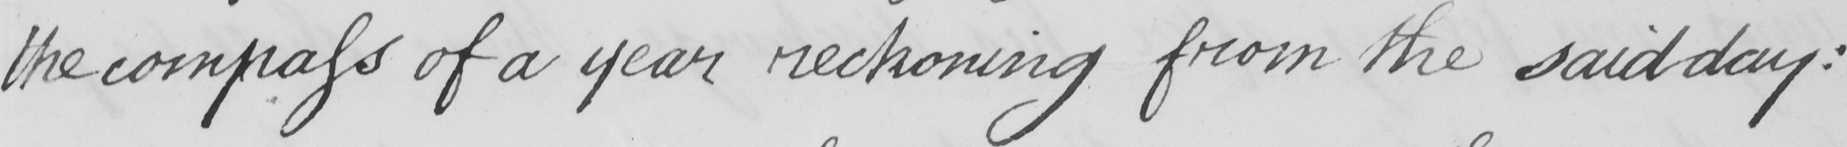What text is written in this handwritten line? the compass of a year reckoning from the said day : 